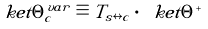<formula> <loc_0><loc_0><loc_500><loc_500>\ k e t { \Theta _ { c } ^ { v a r } } \equiv T _ { s \leftrightarrow c } \cdot \ k e t { \Theta ^ { + } }</formula> 